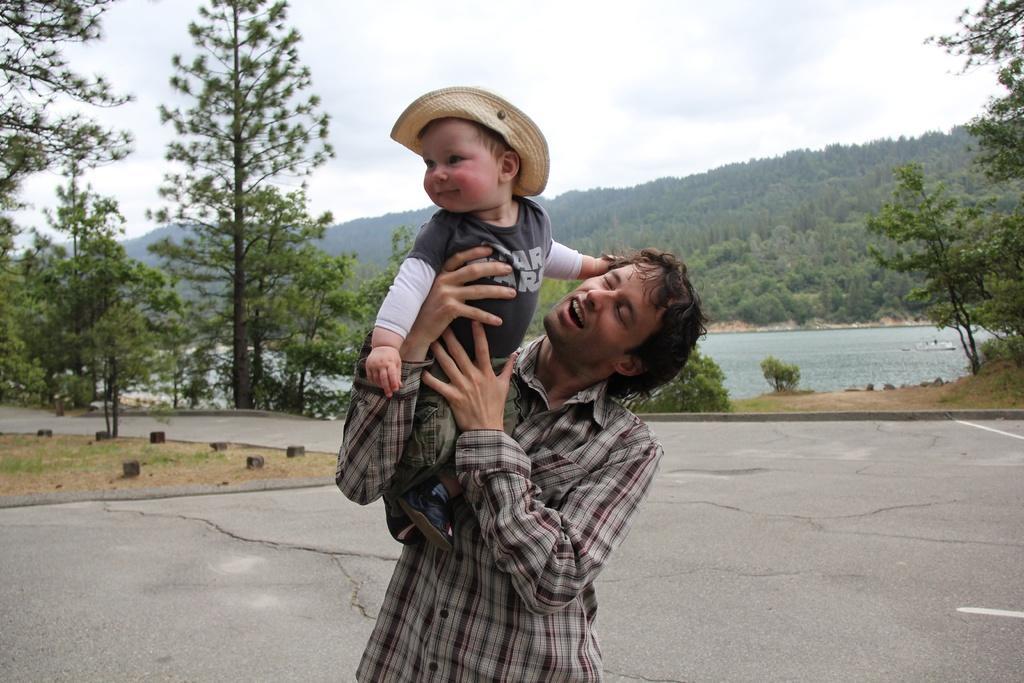Please provide a concise description of this image. In this picture we can observe a man holding a baby in his hands. The baby is wearing a hat on his head. The man is wearing a shirt and the baby is wearing T shirt. We can observe road. There is a river. We can observe some trees. In the background there are hills and a sky with clouds. 